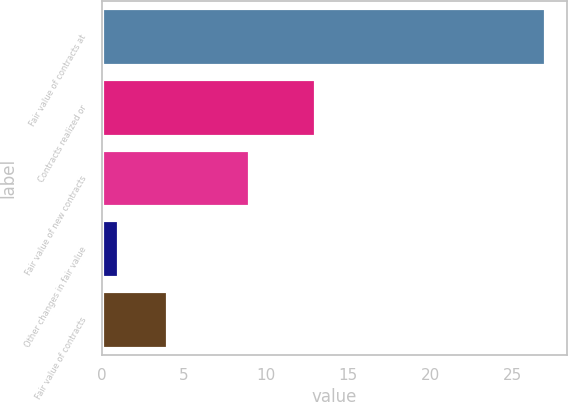Convert chart to OTSL. <chart><loc_0><loc_0><loc_500><loc_500><bar_chart><fcel>Fair value of contracts at<fcel>Contracts realized or<fcel>Fair value of new contracts<fcel>Other changes in fair value<fcel>Fair value of contracts<nl><fcel>27<fcel>13<fcel>9<fcel>1<fcel>4<nl></chart> 